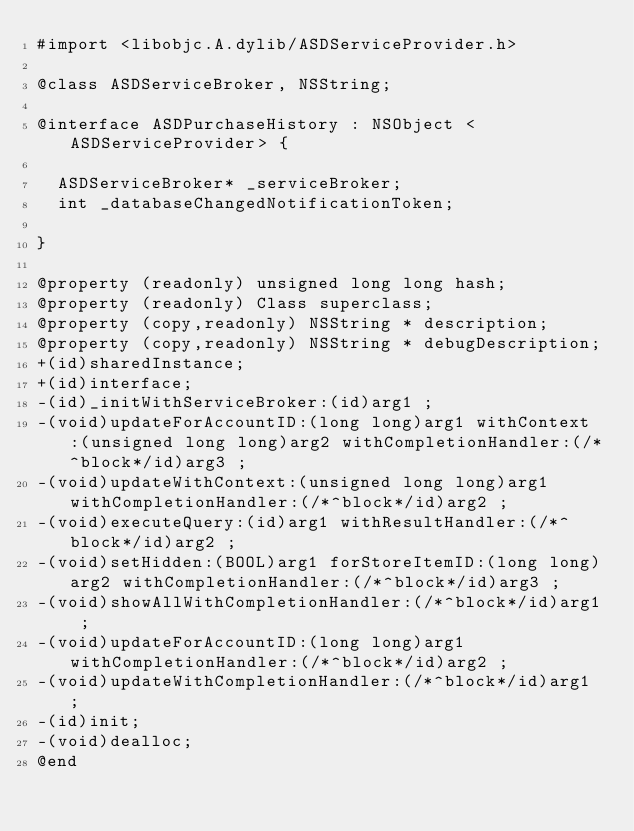Convert code to text. <code><loc_0><loc_0><loc_500><loc_500><_C_>#import <libobjc.A.dylib/ASDServiceProvider.h>

@class ASDServiceBroker, NSString;

@interface ASDPurchaseHistory : NSObject <ASDServiceProvider> {

	ASDServiceBroker* _serviceBroker;
	int _databaseChangedNotificationToken;

}

@property (readonly) unsigned long long hash; 
@property (readonly) Class superclass; 
@property (copy,readonly) NSString * description; 
@property (copy,readonly) NSString * debugDescription; 
+(id)sharedInstance;
+(id)interface;
-(id)_initWithServiceBroker:(id)arg1 ;
-(void)updateForAccountID:(long long)arg1 withContext:(unsigned long long)arg2 withCompletionHandler:(/*^block*/id)arg3 ;
-(void)updateWithContext:(unsigned long long)arg1 withCompletionHandler:(/*^block*/id)arg2 ;
-(void)executeQuery:(id)arg1 withResultHandler:(/*^block*/id)arg2 ;
-(void)setHidden:(BOOL)arg1 forStoreItemID:(long long)arg2 withCompletionHandler:(/*^block*/id)arg3 ;
-(void)showAllWithCompletionHandler:(/*^block*/id)arg1 ;
-(void)updateForAccountID:(long long)arg1 withCompletionHandler:(/*^block*/id)arg2 ;
-(void)updateWithCompletionHandler:(/*^block*/id)arg1 ;
-(id)init;
-(void)dealloc;
@end

</code> 